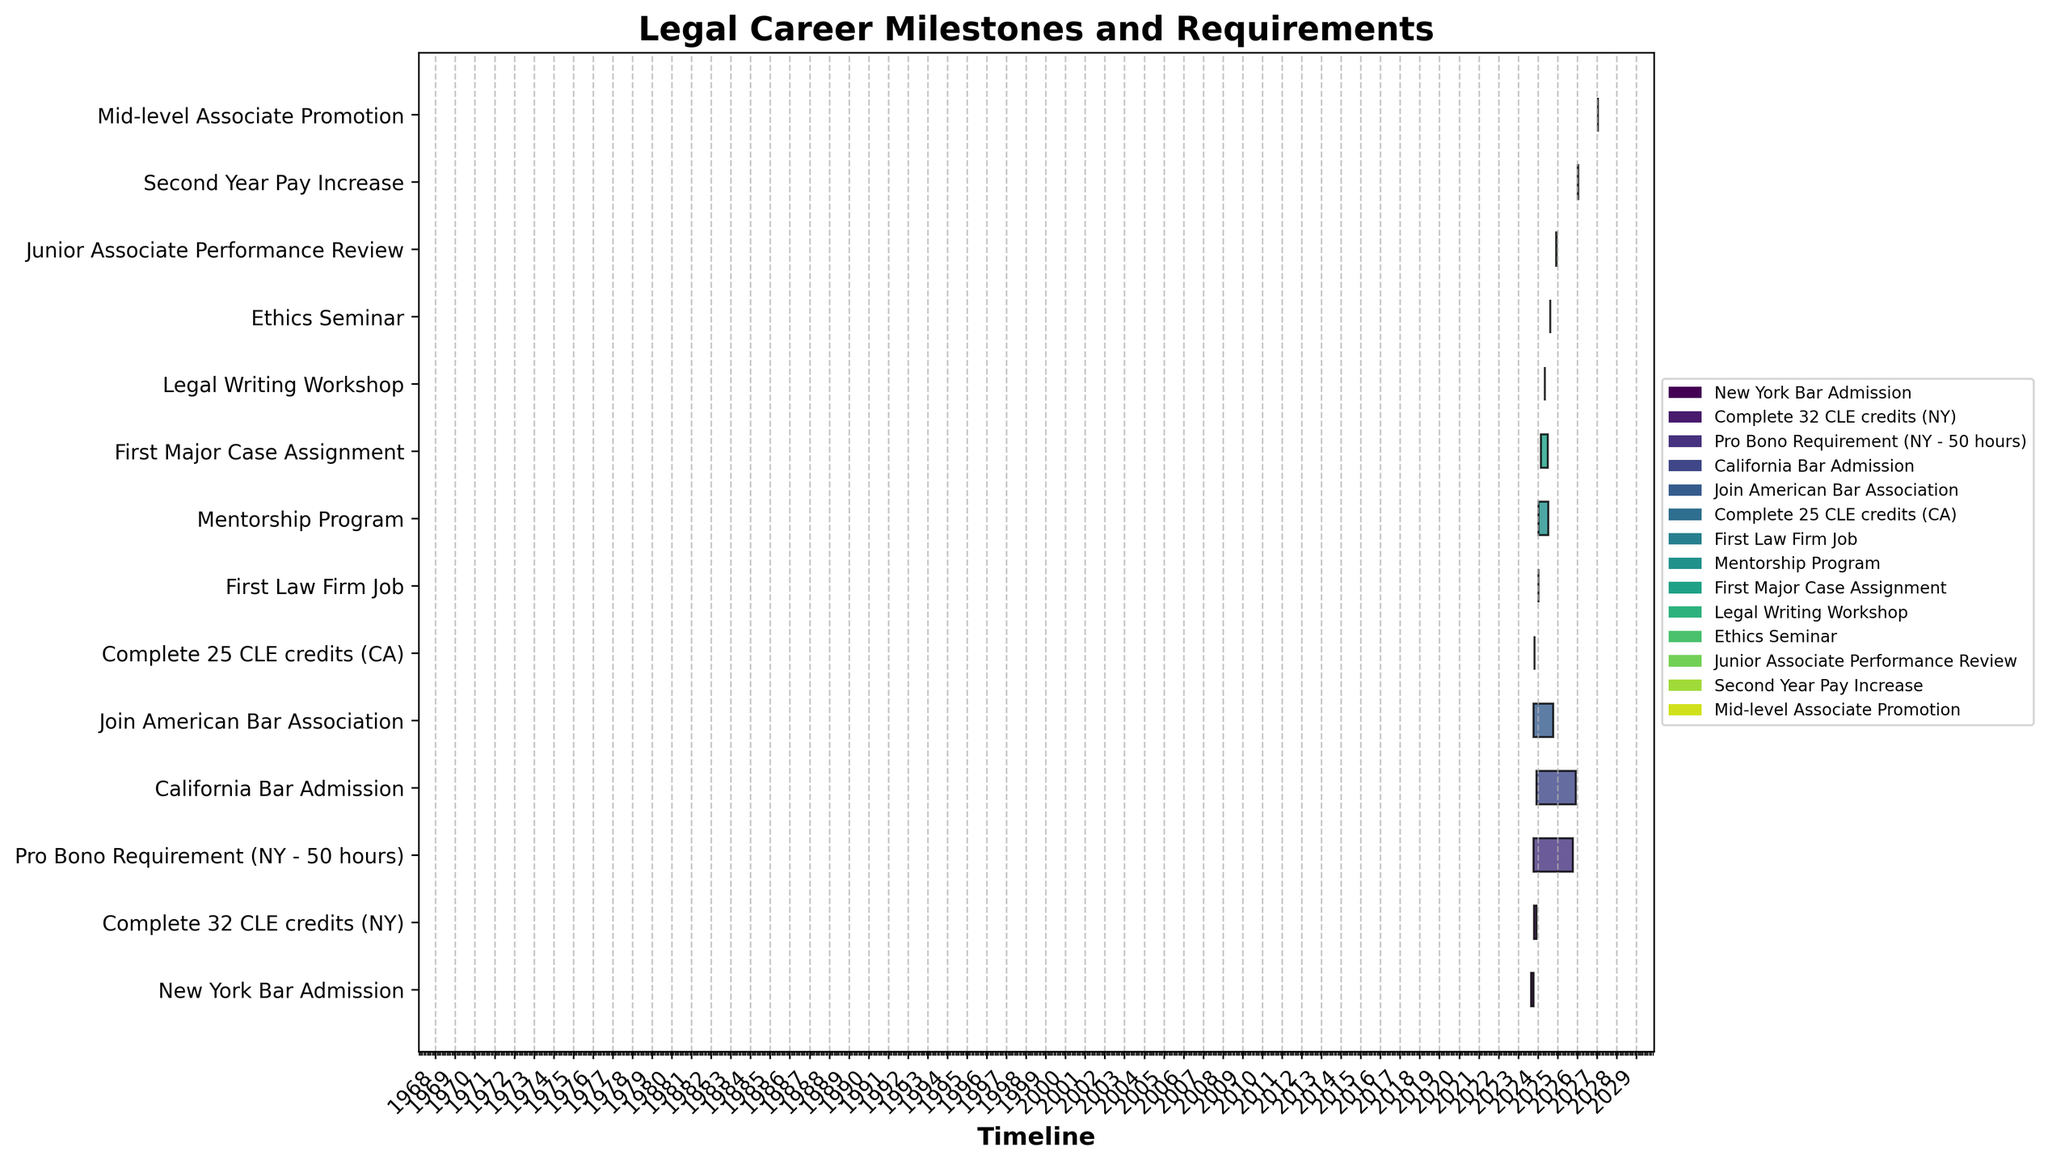What is the title of the Gantt chart? The title of a Gantt chart is usually positioned at the top of the chart and can be read easily by looking there.
Answer: Legal Career Milestones and Requirements Which task begins first in the timeline? To find which task begins first, look for the task bar that starts earliest on the chart's horizontal timeline.
Answer: New York Bar Admission How many CLE credits are required to be completed in New York? Identify the task related to CLE credit requirements for New York and read the corresponding label.
Answer: 32 CLE credits What is the duration of the Mentorship Program? Determine the start and end dates of the Mentorship Program task and calculate the difference in days.
Answer: 6 months Which task has the shortest duration? Look at the Gantt chart to find the task with the narrowest bar, as this indicates the shortest duration.
Answer: Join American Bar Association How long after the New York Bar Admission does the Pro Bono Requirement last? First, find the start date of the New York Bar Admission and Pro Bono Requirement tasks. Then calculate the difference between the start dates.
Answer: 1 month Which continues longer: the Pro Bono Requirement in New York or the completion of CLE credits in California? Compare the lengths of the bars for the Pro Bono Requirement task in New York and the CLE credits task in California.
Answer: Complete 25 CLE credits (CA) Does the First Law Firm Job start before or after the completion of the Pro Bono Requirement? Compare the start date of the First Law Firm Job task with the end date of the Pro Bono Requirement task.
Answer: After How much time is there between starting the First Major Case Assignment and the Legal Writing Workshop? Find the start dates of both tasks and calculate the difference between them in days.
Answer: About 2 months Which milestone involves a pay increase and when does it occur? Identify the task related to a pay increase and note its associated start date.
Answer: Second Year Pay Increase, 2026-01-15 